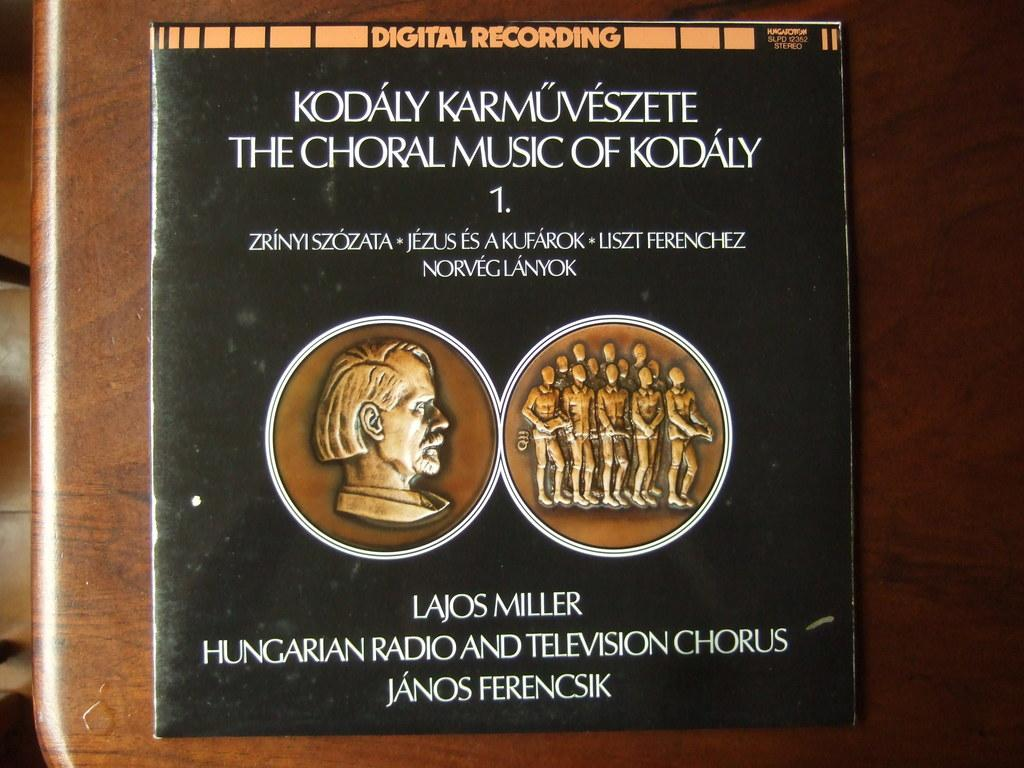<image>
Provide a brief description of the given image. A black record cover for the Hungarian Radio and Television Chorus. 